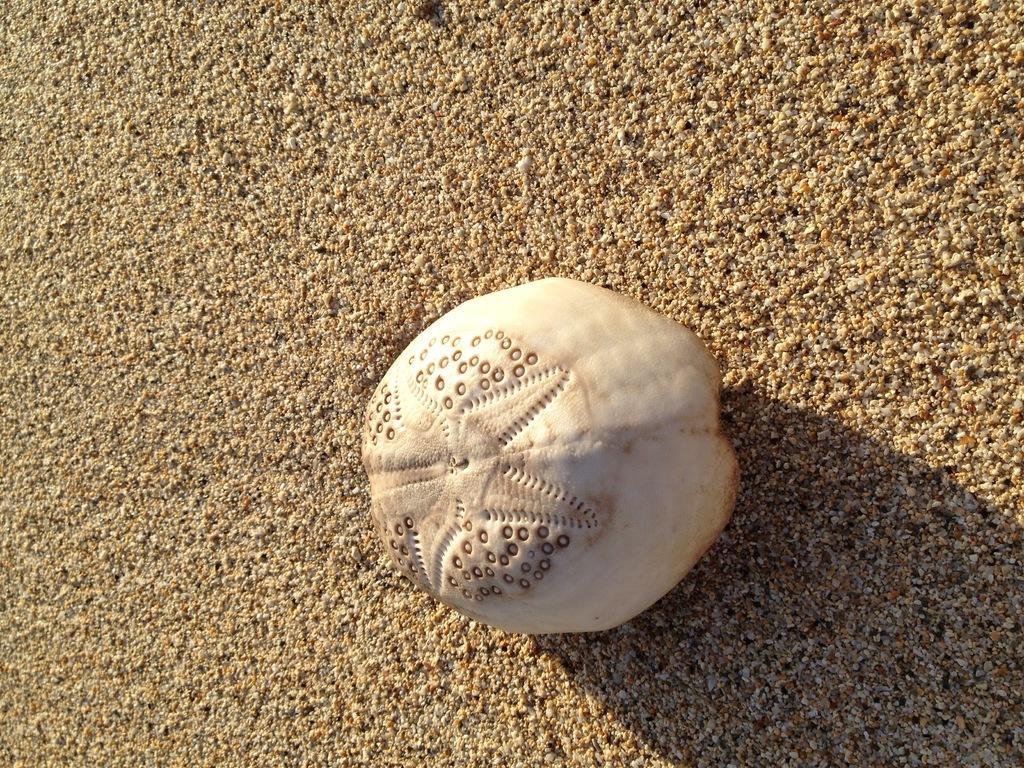Could you give a brief overview of what you see in this image? It is a white color thing on the sand. 